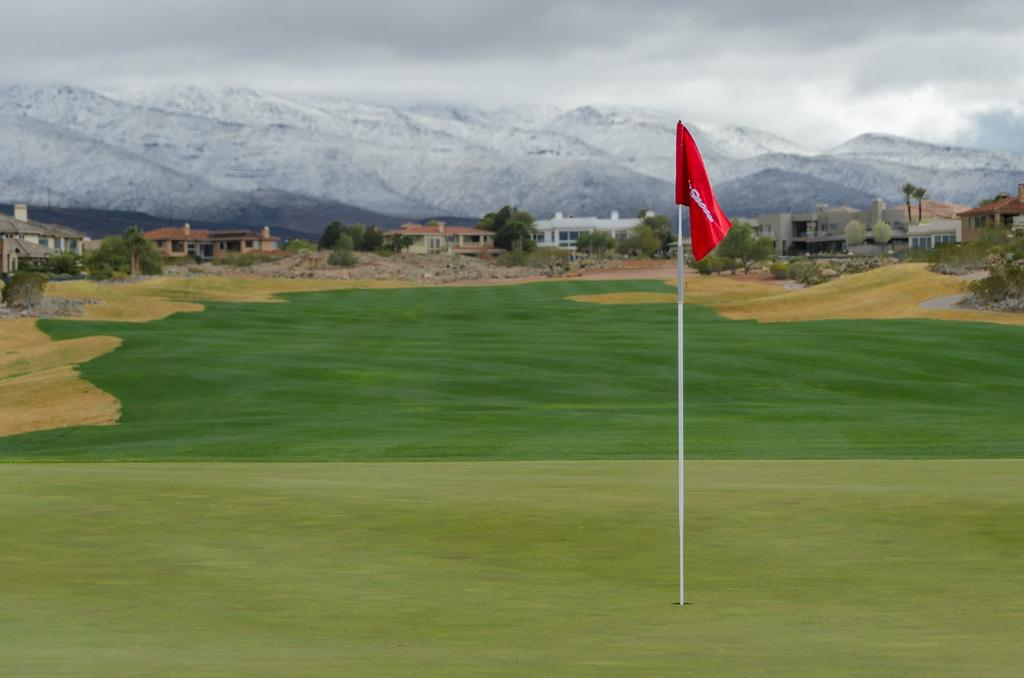What can be seen in the golf ground in the image? There is a flag in the golf ground in the image. What type of natural elements are visible in the image? Trees are visible in the image. What man-made structures can be seen in the image? Buildings are present in the image. What type of landscape feature is visible in the distance? Mountains are visible in the image. What is visible in the background of the image? The sky is in the background of the image. What type of cat can be seen climbing the flagpole in the image? There is no cat present in the image, and therefore no such activity can be observed. 